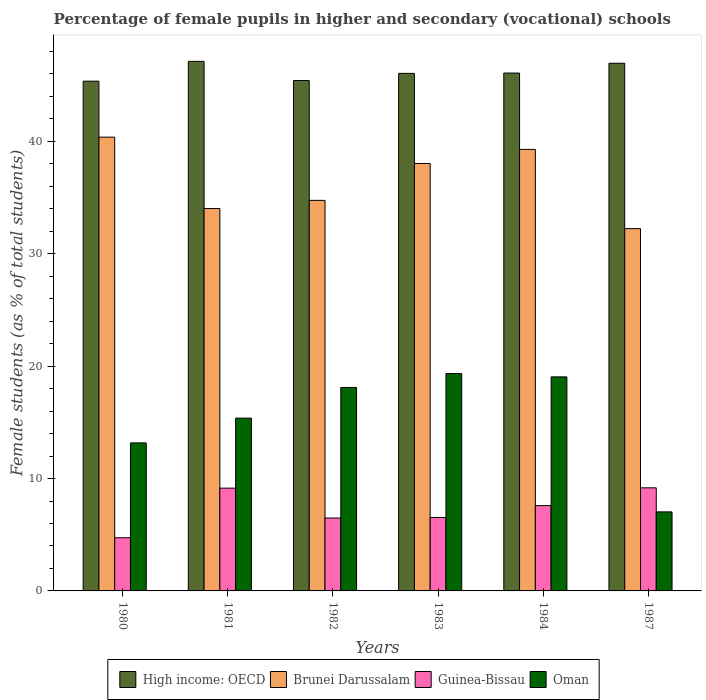How many different coloured bars are there?
Your response must be concise. 4. How many groups of bars are there?
Make the answer very short. 6. What is the percentage of female pupils in higher and secondary schools in Brunei Darussalam in 1980?
Give a very brief answer. 40.37. Across all years, what is the maximum percentage of female pupils in higher and secondary schools in High income: OECD?
Your response must be concise. 47.12. Across all years, what is the minimum percentage of female pupils in higher and secondary schools in Guinea-Bissau?
Keep it short and to the point. 4.73. In which year was the percentage of female pupils in higher and secondary schools in Oman maximum?
Make the answer very short. 1983. In which year was the percentage of female pupils in higher and secondary schools in High income: OECD minimum?
Offer a terse response. 1980. What is the total percentage of female pupils in higher and secondary schools in Brunei Darussalam in the graph?
Make the answer very short. 218.69. What is the difference between the percentage of female pupils in higher and secondary schools in Oman in 1981 and that in 1987?
Your answer should be compact. 8.34. What is the difference between the percentage of female pupils in higher and secondary schools in Guinea-Bissau in 1981 and the percentage of female pupils in higher and secondary schools in Oman in 1982?
Your answer should be very brief. -8.96. What is the average percentage of female pupils in higher and secondary schools in Oman per year?
Your response must be concise. 15.34. In the year 1982, what is the difference between the percentage of female pupils in higher and secondary schools in Brunei Darussalam and percentage of female pupils in higher and secondary schools in Guinea-Bissau?
Offer a terse response. 28.26. In how many years, is the percentage of female pupils in higher and secondary schools in High income: OECD greater than 38 %?
Your answer should be compact. 6. What is the ratio of the percentage of female pupils in higher and secondary schools in Oman in 1981 to that in 1984?
Provide a succinct answer. 0.81. Is the percentage of female pupils in higher and secondary schools in Brunei Darussalam in 1983 less than that in 1987?
Offer a terse response. No. What is the difference between the highest and the second highest percentage of female pupils in higher and secondary schools in High income: OECD?
Provide a succinct answer. 0.17. What is the difference between the highest and the lowest percentage of female pupils in higher and secondary schools in High income: OECD?
Your answer should be compact. 1.76. Is it the case that in every year, the sum of the percentage of female pupils in higher and secondary schools in Guinea-Bissau and percentage of female pupils in higher and secondary schools in Oman is greater than the sum of percentage of female pupils in higher and secondary schools in Brunei Darussalam and percentage of female pupils in higher and secondary schools in High income: OECD?
Provide a succinct answer. Yes. What does the 4th bar from the left in 1984 represents?
Provide a succinct answer. Oman. What does the 4th bar from the right in 1987 represents?
Ensure brevity in your answer.  High income: OECD. Are all the bars in the graph horizontal?
Your answer should be compact. No. What is the difference between two consecutive major ticks on the Y-axis?
Offer a terse response. 10. Are the values on the major ticks of Y-axis written in scientific E-notation?
Your answer should be very brief. No. Where does the legend appear in the graph?
Give a very brief answer. Bottom center. How many legend labels are there?
Your answer should be compact. 4. What is the title of the graph?
Provide a succinct answer. Percentage of female pupils in higher and secondary (vocational) schools. What is the label or title of the X-axis?
Provide a succinct answer. Years. What is the label or title of the Y-axis?
Provide a short and direct response. Female students (as % of total students). What is the Female students (as % of total students) in High income: OECD in 1980?
Offer a terse response. 45.35. What is the Female students (as % of total students) in Brunei Darussalam in 1980?
Your answer should be compact. 40.37. What is the Female students (as % of total students) of Guinea-Bissau in 1980?
Your answer should be very brief. 4.73. What is the Female students (as % of total students) of Oman in 1980?
Your answer should be compact. 13.17. What is the Female students (as % of total students) in High income: OECD in 1981?
Keep it short and to the point. 47.12. What is the Female students (as % of total students) of Brunei Darussalam in 1981?
Keep it short and to the point. 34.02. What is the Female students (as % of total students) of Guinea-Bissau in 1981?
Your response must be concise. 9.14. What is the Female students (as % of total students) in Oman in 1981?
Your answer should be very brief. 15.37. What is the Female students (as % of total students) of High income: OECD in 1982?
Provide a succinct answer. 45.41. What is the Female students (as % of total students) in Brunei Darussalam in 1982?
Your answer should be compact. 34.75. What is the Female students (as % of total students) of Guinea-Bissau in 1982?
Keep it short and to the point. 6.49. What is the Female students (as % of total students) in Oman in 1982?
Make the answer very short. 18.1. What is the Female students (as % of total students) of High income: OECD in 1983?
Make the answer very short. 46.05. What is the Female students (as % of total students) of Brunei Darussalam in 1983?
Ensure brevity in your answer.  38.03. What is the Female students (as % of total students) in Guinea-Bissau in 1983?
Give a very brief answer. 6.54. What is the Female students (as % of total students) of Oman in 1983?
Your answer should be compact. 19.34. What is the Female students (as % of total students) in High income: OECD in 1984?
Your answer should be very brief. 46.08. What is the Female students (as % of total students) in Brunei Darussalam in 1984?
Your answer should be compact. 39.28. What is the Female students (as % of total students) of Guinea-Bissau in 1984?
Make the answer very short. 7.59. What is the Female students (as % of total students) of Oman in 1984?
Make the answer very short. 19.04. What is the Female students (as % of total students) of High income: OECD in 1987?
Provide a succinct answer. 46.95. What is the Female students (as % of total students) in Brunei Darussalam in 1987?
Offer a terse response. 32.24. What is the Female students (as % of total students) in Guinea-Bissau in 1987?
Your answer should be compact. 9.17. What is the Female students (as % of total students) in Oman in 1987?
Offer a terse response. 7.03. Across all years, what is the maximum Female students (as % of total students) in High income: OECD?
Provide a succinct answer. 47.12. Across all years, what is the maximum Female students (as % of total students) in Brunei Darussalam?
Ensure brevity in your answer.  40.37. Across all years, what is the maximum Female students (as % of total students) of Guinea-Bissau?
Give a very brief answer. 9.17. Across all years, what is the maximum Female students (as % of total students) in Oman?
Your response must be concise. 19.34. Across all years, what is the minimum Female students (as % of total students) in High income: OECD?
Provide a short and direct response. 45.35. Across all years, what is the minimum Female students (as % of total students) of Brunei Darussalam?
Offer a terse response. 32.24. Across all years, what is the minimum Female students (as % of total students) in Guinea-Bissau?
Provide a short and direct response. 4.73. Across all years, what is the minimum Female students (as % of total students) in Oman?
Your answer should be very brief. 7.03. What is the total Female students (as % of total students) of High income: OECD in the graph?
Give a very brief answer. 276.96. What is the total Female students (as % of total students) of Brunei Darussalam in the graph?
Provide a succinct answer. 218.69. What is the total Female students (as % of total students) of Guinea-Bissau in the graph?
Offer a very short reply. 43.66. What is the total Female students (as % of total students) in Oman in the graph?
Offer a very short reply. 92.07. What is the difference between the Female students (as % of total students) in High income: OECD in 1980 and that in 1981?
Your answer should be very brief. -1.76. What is the difference between the Female students (as % of total students) of Brunei Darussalam in 1980 and that in 1981?
Provide a succinct answer. 6.35. What is the difference between the Female students (as % of total students) of Guinea-Bissau in 1980 and that in 1981?
Offer a very short reply. -4.41. What is the difference between the Female students (as % of total students) in Oman in 1980 and that in 1981?
Offer a terse response. -2.2. What is the difference between the Female students (as % of total students) of High income: OECD in 1980 and that in 1982?
Offer a terse response. -0.06. What is the difference between the Female students (as % of total students) of Brunei Darussalam in 1980 and that in 1982?
Offer a very short reply. 5.62. What is the difference between the Female students (as % of total students) of Guinea-Bissau in 1980 and that in 1982?
Provide a short and direct response. -1.75. What is the difference between the Female students (as % of total students) of Oman in 1980 and that in 1982?
Your answer should be very brief. -4.93. What is the difference between the Female students (as % of total students) in High income: OECD in 1980 and that in 1983?
Give a very brief answer. -0.69. What is the difference between the Female students (as % of total students) in Brunei Darussalam in 1980 and that in 1983?
Ensure brevity in your answer.  2.34. What is the difference between the Female students (as % of total students) of Guinea-Bissau in 1980 and that in 1983?
Offer a very short reply. -1.8. What is the difference between the Female students (as % of total students) of Oman in 1980 and that in 1983?
Your response must be concise. -6.17. What is the difference between the Female students (as % of total students) in High income: OECD in 1980 and that in 1984?
Your answer should be compact. -0.72. What is the difference between the Female students (as % of total students) in Brunei Darussalam in 1980 and that in 1984?
Offer a very short reply. 1.09. What is the difference between the Female students (as % of total students) of Guinea-Bissau in 1980 and that in 1984?
Make the answer very short. -2.86. What is the difference between the Female students (as % of total students) in Oman in 1980 and that in 1984?
Ensure brevity in your answer.  -5.87. What is the difference between the Female students (as % of total students) in High income: OECD in 1980 and that in 1987?
Your response must be concise. -1.6. What is the difference between the Female students (as % of total students) in Brunei Darussalam in 1980 and that in 1987?
Your answer should be compact. 8.14. What is the difference between the Female students (as % of total students) in Guinea-Bissau in 1980 and that in 1987?
Your answer should be very brief. -4.44. What is the difference between the Female students (as % of total students) of Oman in 1980 and that in 1987?
Your answer should be compact. 6.14. What is the difference between the Female students (as % of total students) in High income: OECD in 1981 and that in 1982?
Keep it short and to the point. 1.71. What is the difference between the Female students (as % of total students) of Brunei Darussalam in 1981 and that in 1982?
Provide a short and direct response. -0.73. What is the difference between the Female students (as % of total students) in Guinea-Bissau in 1981 and that in 1982?
Offer a terse response. 2.66. What is the difference between the Female students (as % of total students) of Oman in 1981 and that in 1982?
Offer a terse response. -2.73. What is the difference between the Female students (as % of total students) of High income: OECD in 1981 and that in 1983?
Offer a terse response. 1.07. What is the difference between the Female students (as % of total students) of Brunei Darussalam in 1981 and that in 1983?
Make the answer very short. -4.01. What is the difference between the Female students (as % of total students) of Guinea-Bissau in 1981 and that in 1983?
Keep it short and to the point. 2.61. What is the difference between the Female students (as % of total students) in Oman in 1981 and that in 1983?
Your answer should be very brief. -3.97. What is the difference between the Female students (as % of total students) of High income: OECD in 1981 and that in 1984?
Provide a succinct answer. 1.04. What is the difference between the Female students (as % of total students) of Brunei Darussalam in 1981 and that in 1984?
Make the answer very short. -5.26. What is the difference between the Female students (as % of total students) of Guinea-Bissau in 1981 and that in 1984?
Ensure brevity in your answer.  1.55. What is the difference between the Female students (as % of total students) in Oman in 1981 and that in 1984?
Provide a short and direct response. -3.67. What is the difference between the Female students (as % of total students) of High income: OECD in 1981 and that in 1987?
Your response must be concise. 0.17. What is the difference between the Female students (as % of total students) in Brunei Darussalam in 1981 and that in 1987?
Keep it short and to the point. 1.79. What is the difference between the Female students (as % of total students) of Guinea-Bissau in 1981 and that in 1987?
Keep it short and to the point. -0.03. What is the difference between the Female students (as % of total students) of Oman in 1981 and that in 1987?
Your answer should be very brief. 8.34. What is the difference between the Female students (as % of total students) of High income: OECD in 1982 and that in 1983?
Offer a very short reply. -0.64. What is the difference between the Female students (as % of total students) of Brunei Darussalam in 1982 and that in 1983?
Provide a short and direct response. -3.28. What is the difference between the Female students (as % of total students) in Guinea-Bissau in 1982 and that in 1983?
Ensure brevity in your answer.  -0.05. What is the difference between the Female students (as % of total students) in Oman in 1982 and that in 1983?
Provide a succinct answer. -1.24. What is the difference between the Female students (as % of total students) in High income: OECD in 1982 and that in 1984?
Your answer should be compact. -0.67. What is the difference between the Female students (as % of total students) of Brunei Darussalam in 1982 and that in 1984?
Keep it short and to the point. -4.53. What is the difference between the Female students (as % of total students) of Guinea-Bissau in 1982 and that in 1984?
Keep it short and to the point. -1.1. What is the difference between the Female students (as % of total students) of Oman in 1982 and that in 1984?
Your response must be concise. -0.94. What is the difference between the Female students (as % of total students) of High income: OECD in 1982 and that in 1987?
Make the answer very short. -1.54. What is the difference between the Female students (as % of total students) in Brunei Darussalam in 1982 and that in 1987?
Ensure brevity in your answer.  2.51. What is the difference between the Female students (as % of total students) in Guinea-Bissau in 1982 and that in 1987?
Provide a succinct answer. -2.69. What is the difference between the Female students (as % of total students) of Oman in 1982 and that in 1987?
Keep it short and to the point. 11.07. What is the difference between the Female students (as % of total students) of High income: OECD in 1983 and that in 1984?
Your response must be concise. -0.03. What is the difference between the Female students (as % of total students) in Brunei Darussalam in 1983 and that in 1984?
Make the answer very short. -1.25. What is the difference between the Female students (as % of total students) of Guinea-Bissau in 1983 and that in 1984?
Make the answer very short. -1.05. What is the difference between the Female students (as % of total students) in Oman in 1983 and that in 1984?
Your answer should be compact. 0.3. What is the difference between the Female students (as % of total students) in High income: OECD in 1983 and that in 1987?
Your answer should be compact. -0.9. What is the difference between the Female students (as % of total students) in Brunei Darussalam in 1983 and that in 1987?
Offer a very short reply. 5.79. What is the difference between the Female students (as % of total students) in Guinea-Bissau in 1983 and that in 1987?
Provide a short and direct response. -2.64. What is the difference between the Female students (as % of total students) in Oman in 1983 and that in 1987?
Make the answer very short. 12.31. What is the difference between the Female students (as % of total students) in High income: OECD in 1984 and that in 1987?
Provide a succinct answer. -0.87. What is the difference between the Female students (as % of total students) in Brunei Darussalam in 1984 and that in 1987?
Your answer should be very brief. 7.05. What is the difference between the Female students (as % of total students) in Guinea-Bissau in 1984 and that in 1987?
Keep it short and to the point. -1.58. What is the difference between the Female students (as % of total students) of Oman in 1984 and that in 1987?
Offer a very short reply. 12.01. What is the difference between the Female students (as % of total students) of High income: OECD in 1980 and the Female students (as % of total students) of Brunei Darussalam in 1981?
Offer a terse response. 11.33. What is the difference between the Female students (as % of total students) of High income: OECD in 1980 and the Female students (as % of total students) of Guinea-Bissau in 1981?
Offer a terse response. 36.21. What is the difference between the Female students (as % of total students) of High income: OECD in 1980 and the Female students (as % of total students) of Oman in 1981?
Provide a short and direct response. 29.98. What is the difference between the Female students (as % of total students) in Brunei Darussalam in 1980 and the Female students (as % of total students) in Guinea-Bissau in 1981?
Make the answer very short. 31.23. What is the difference between the Female students (as % of total students) of Brunei Darussalam in 1980 and the Female students (as % of total students) of Oman in 1981?
Offer a very short reply. 25. What is the difference between the Female students (as % of total students) in Guinea-Bissau in 1980 and the Female students (as % of total students) in Oman in 1981?
Your response must be concise. -10.64. What is the difference between the Female students (as % of total students) of High income: OECD in 1980 and the Female students (as % of total students) of Brunei Darussalam in 1982?
Make the answer very short. 10.61. What is the difference between the Female students (as % of total students) of High income: OECD in 1980 and the Female students (as % of total students) of Guinea-Bissau in 1982?
Ensure brevity in your answer.  38.87. What is the difference between the Female students (as % of total students) in High income: OECD in 1980 and the Female students (as % of total students) in Oman in 1982?
Keep it short and to the point. 27.25. What is the difference between the Female students (as % of total students) in Brunei Darussalam in 1980 and the Female students (as % of total students) in Guinea-Bissau in 1982?
Offer a terse response. 33.89. What is the difference between the Female students (as % of total students) of Brunei Darussalam in 1980 and the Female students (as % of total students) of Oman in 1982?
Keep it short and to the point. 22.27. What is the difference between the Female students (as % of total students) of Guinea-Bissau in 1980 and the Female students (as % of total students) of Oman in 1982?
Provide a succinct answer. -13.37. What is the difference between the Female students (as % of total students) of High income: OECD in 1980 and the Female students (as % of total students) of Brunei Darussalam in 1983?
Give a very brief answer. 7.33. What is the difference between the Female students (as % of total students) in High income: OECD in 1980 and the Female students (as % of total students) in Guinea-Bissau in 1983?
Offer a very short reply. 38.82. What is the difference between the Female students (as % of total students) in High income: OECD in 1980 and the Female students (as % of total students) in Oman in 1983?
Your answer should be very brief. 26.01. What is the difference between the Female students (as % of total students) of Brunei Darussalam in 1980 and the Female students (as % of total students) of Guinea-Bissau in 1983?
Offer a very short reply. 33.84. What is the difference between the Female students (as % of total students) of Brunei Darussalam in 1980 and the Female students (as % of total students) of Oman in 1983?
Keep it short and to the point. 21.03. What is the difference between the Female students (as % of total students) in Guinea-Bissau in 1980 and the Female students (as % of total students) in Oman in 1983?
Your answer should be compact. -14.61. What is the difference between the Female students (as % of total students) of High income: OECD in 1980 and the Female students (as % of total students) of Brunei Darussalam in 1984?
Make the answer very short. 6.07. What is the difference between the Female students (as % of total students) of High income: OECD in 1980 and the Female students (as % of total students) of Guinea-Bissau in 1984?
Make the answer very short. 37.76. What is the difference between the Female students (as % of total students) in High income: OECD in 1980 and the Female students (as % of total students) in Oman in 1984?
Your answer should be very brief. 26.31. What is the difference between the Female students (as % of total students) in Brunei Darussalam in 1980 and the Female students (as % of total students) in Guinea-Bissau in 1984?
Your answer should be compact. 32.78. What is the difference between the Female students (as % of total students) of Brunei Darussalam in 1980 and the Female students (as % of total students) of Oman in 1984?
Your answer should be very brief. 21.33. What is the difference between the Female students (as % of total students) in Guinea-Bissau in 1980 and the Female students (as % of total students) in Oman in 1984?
Give a very brief answer. -14.31. What is the difference between the Female students (as % of total students) of High income: OECD in 1980 and the Female students (as % of total students) of Brunei Darussalam in 1987?
Your response must be concise. 13.12. What is the difference between the Female students (as % of total students) in High income: OECD in 1980 and the Female students (as % of total students) in Guinea-Bissau in 1987?
Give a very brief answer. 36.18. What is the difference between the Female students (as % of total students) in High income: OECD in 1980 and the Female students (as % of total students) in Oman in 1987?
Offer a terse response. 38.32. What is the difference between the Female students (as % of total students) in Brunei Darussalam in 1980 and the Female students (as % of total students) in Guinea-Bissau in 1987?
Make the answer very short. 31.2. What is the difference between the Female students (as % of total students) of Brunei Darussalam in 1980 and the Female students (as % of total students) of Oman in 1987?
Provide a succinct answer. 33.34. What is the difference between the Female students (as % of total students) of Guinea-Bissau in 1980 and the Female students (as % of total students) of Oman in 1987?
Provide a short and direct response. -2.3. What is the difference between the Female students (as % of total students) in High income: OECD in 1981 and the Female students (as % of total students) in Brunei Darussalam in 1982?
Provide a succinct answer. 12.37. What is the difference between the Female students (as % of total students) of High income: OECD in 1981 and the Female students (as % of total students) of Guinea-Bissau in 1982?
Your answer should be very brief. 40.63. What is the difference between the Female students (as % of total students) in High income: OECD in 1981 and the Female students (as % of total students) in Oman in 1982?
Offer a terse response. 29.01. What is the difference between the Female students (as % of total students) in Brunei Darussalam in 1981 and the Female students (as % of total students) in Guinea-Bissau in 1982?
Ensure brevity in your answer.  27.54. What is the difference between the Female students (as % of total students) of Brunei Darussalam in 1981 and the Female students (as % of total students) of Oman in 1982?
Provide a succinct answer. 15.92. What is the difference between the Female students (as % of total students) of Guinea-Bissau in 1981 and the Female students (as % of total students) of Oman in 1982?
Provide a succinct answer. -8.96. What is the difference between the Female students (as % of total students) of High income: OECD in 1981 and the Female students (as % of total students) of Brunei Darussalam in 1983?
Keep it short and to the point. 9.09. What is the difference between the Female students (as % of total students) in High income: OECD in 1981 and the Female students (as % of total students) in Guinea-Bissau in 1983?
Provide a short and direct response. 40.58. What is the difference between the Female students (as % of total students) of High income: OECD in 1981 and the Female students (as % of total students) of Oman in 1983?
Provide a short and direct response. 27.78. What is the difference between the Female students (as % of total students) in Brunei Darussalam in 1981 and the Female students (as % of total students) in Guinea-Bissau in 1983?
Offer a very short reply. 27.49. What is the difference between the Female students (as % of total students) of Brunei Darussalam in 1981 and the Female students (as % of total students) of Oman in 1983?
Offer a terse response. 14.68. What is the difference between the Female students (as % of total students) in Guinea-Bissau in 1981 and the Female students (as % of total students) in Oman in 1983?
Give a very brief answer. -10.2. What is the difference between the Female students (as % of total students) of High income: OECD in 1981 and the Female students (as % of total students) of Brunei Darussalam in 1984?
Ensure brevity in your answer.  7.83. What is the difference between the Female students (as % of total students) in High income: OECD in 1981 and the Female students (as % of total students) in Guinea-Bissau in 1984?
Your response must be concise. 39.53. What is the difference between the Female students (as % of total students) of High income: OECD in 1981 and the Female students (as % of total students) of Oman in 1984?
Your answer should be compact. 28.07. What is the difference between the Female students (as % of total students) of Brunei Darussalam in 1981 and the Female students (as % of total students) of Guinea-Bissau in 1984?
Keep it short and to the point. 26.43. What is the difference between the Female students (as % of total students) of Brunei Darussalam in 1981 and the Female students (as % of total students) of Oman in 1984?
Offer a very short reply. 14.98. What is the difference between the Female students (as % of total students) in Guinea-Bissau in 1981 and the Female students (as % of total students) in Oman in 1984?
Make the answer very short. -9.9. What is the difference between the Female students (as % of total students) in High income: OECD in 1981 and the Female students (as % of total students) in Brunei Darussalam in 1987?
Give a very brief answer. 14.88. What is the difference between the Female students (as % of total students) of High income: OECD in 1981 and the Female students (as % of total students) of Guinea-Bissau in 1987?
Offer a very short reply. 37.95. What is the difference between the Female students (as % of total students) of High income: OECD in 1981 and the Female students (as % of total students) of Oman in 1987?
Give a very brief answer. 40.08. What is the difference between the Female students (as % of total students) of Brunei Darussalam in 1981 and the Female students (as % of total students) of Guinea-Bissau in 1987?
Provide a short and direct response. 24.85. What is the difference between the Female students (as % of total students) in Brunei Darussalam in 1981 and the Female students (as % of total students) in Oman in 1987?
Your response must be concise. 26.99. What is the difference between the Female students (as % of total students) of Guinea-Bissau in 1981 and the Female students (as % of total students) of Oman in 1987?
Your answer should be compact. 2.11. What is the difference between the Female students (as % of total students) of High income: OECD in 1982 and the Female students (as % of total students) of Brunei Darussalam in 1983?
Provide a short and direct response. 7.38. What is the difference between the Female students (as % of total students) of High income: OECD in 1982 and the Female students (as % of total students) of Guinea-Bissau in 1983?
Provide a succinct answer. 38.87. What is the difference between the Female students (as % of total students) in High income: OECD in 1982 and the Female students (as % of total students) in Oman in 1983?
Provide a short and direct response. 26.07. What is the difference between the Female students (as % of total students) in Brunei Darussalam in 1982 and the Female students (as % of total students) in Guinea-Bissau in 1983?
Provide a short and direct response. 28.21. What is the difference between the Female students (as % of total students) in Brunei Darussalam in 1982 and the Female students (as % of total students) in Oman in 1983?
Provide a succinct answer. 15.41. What is the difference between the Female students (as % of total students) in Guinea-Bissau in 1982 and the Female students (as % of total students) in Oman in 1983?
Provide a succinct answer. -12.85. What is the difference between the Female students (as % of total students) of High income: OECD in 1982 and the Female students (as % of total students) of Brunei Darussalam in 1984?
Keep it short and to the point. 6.13. What is the difference between the Female students (as % of total students) in High income: OECD in 1982 and the Female students (as % of total students) in Guinea-Bissau in 1984?
Provide a short and direct response. 37.82. What is the difference between the Female students (as % of total students) in High income: OECD in 1982 and the Female students (as % of total students) in Oman in 1984?
Offer a very short reply. 26.37. What is the difference between the Female students (as % of total students) of Brunei Darussalam in 1982 and the Female students (as % of total students) of Guinea-Bissau in 1984?
Offer a terse response. 27.16. What is the difference between the Female students (as % of total students) in Brunei Darussalam in 1982 and the Female students (as % of total students) in Oman in 1984?
Make the answer very short. 15.7. What is the difference between the Female students (as % of total students) of Guinea-Bissau in 1982 and the Female students (as % of total students) of Oman in 1984?
Provide a short and direct response. -12.56. What is the difference between the Female students (as % of total students) in High income: OECD in 1982 and the Female students (as % of total students) in Brunei Darussalam in 1987?
Your answer should be very brief. 13.17. What is the difference between the Female students (as % of total students) in High income: OECD in 1982 and the Female students (as % of total students) in Guinea-Bissau in 1987?
Ensure brevity in your answer.  36.24. What is the difference between the Female students (as % of total students) of High income: OECD in 1982 and the Female students (as % of total students) of Oman in 1987?
Your answer should be very brief. 38.38. What is the difference between the Female students (as % of total students) of Brunei Darussalam in 1982 and the Female students (as % of total students) of Guinea-Bissau in 1987?
Provide a succinct answer. 25.58. What is the difference between the Female students (as % of total students) of Brunei Darussalam in 1982 and the Female students (as % of total students) of Oman in 1987?
Make the answer very short. 27.72. What is the difference between the Female students (as % of total students) of Guinea-Bissau in 1982 and the Female students (as % of total students) of Oman in 1987?
Make the answer very short. -0.55. What is the difference between the Female students (as % of total students) in High income: OECD in 1983 and the Female students (as % of total students) in Brunei Darussalam in 1984?
Keep it short and to the point. 6.76. What is the difference between the Female students (as % of total students) of High income: OECD in 1983 and the Female students (as % of total students) of Guinea-Bissau in 1984?
Offer a terse response. 38.46. What is the difference between the Female students (as % of total students) in High income: OECD in 1983 and the Female students (as % of total students) in Oman in 1984?
Provide a succinct answer. 27. What is the difference between the Female students (as % of total students) of Brunei Darussalam in 1983 and the Female students (as % of total students) of Guinea-Bissau in 1984?
Provide a succinct answer. 30.44. What is the difference between the Female students (as % of total students) of Brunei Darussalam in 1983 and the Female students (as % of total students) of Oman in 1984?
Provide a short and direct response. 18.99. What is the difference between the Female students (as % of total students) in Guinea-Bissau in 1983 and the Female students (as % of total students) in Oman in 1984?
Offer a terse response. -12.51. What is the difference between the Female students (as % of total students) in High income: OECD in 1983 and the Female students (as % of total students) in Brunei Darussalam in 1987?
Keep it short and to the point. 13.81. What is the difference between the Female students (as % of total students) in High income: OECD in 1983 and the Female students (as % of total students) in Guinea-Bissau in 1987?
Your answer should be very brief. 36.88. What is the difference between the Female students (as % of total students) of High income: OECD in 1983 and the Female students (as % of total students) of Oman in 1987?
Give a very brief answer. 39.02. What is the difference between the Female students (as % of total students) of Brunei Darussalam in 1983 and the Female students (as % of total students) of Guinea-Bissau in 1987?
Your response must be concise. 28.86. What is the difference between the Female students (as % of total students) in Brunei Darussalam in 1983 and the Female students (as % of total students) in Oman in 1987?
Provide a succinct answer. 31. What is the difference between the Female students (as % of total students) in Guinea-Bissau in 1983 and the Female students (as % of total students) in Oman in 1987?
Your answer should be compact. -0.5. What is the difference between the Female students (as % of total students) of High income: OECD in 1984 and the Female students (as % of total students) of Brunei Darussalam in 1987?
Your answer should be compact. 13.84. What is the difference between the Female students (as % of total students) of High income: OECD in 1984 and the Female students (as % of total students) of Guinea-Bissau in 1987?
Offer a very short reply. 36.9. What is the difference between the Female students (as % of total students) in High income: OECD in 1984 and the Female students (as % of total students) in Oman in 1987?
Offer a very short reply. 39.04. What is the difference between the Female students (as % of total students) in Brunei Darussalam in 1984 and the Female students (as % of total students) in Guinea-Bissau in 1987?
Ensure brevity in your answer.  30.11. What is the difference between the Female students (as % of total students) of Brunei Darussalam in 1984 and the Female students (as % of total students) of Oman in 1987?
Provide a succinct answer. 32.25. What is the difference between the Female students (as % of total students) in Guinea-Bissau in 1984 and the Female students (as % of total students) in Oman in 1987?
Give a very brief answer. 0.56. What is the average Female students (as % of total students) in High income: OECD per year?
Provide a short and direct response. 46.16. What is the average Female students (as % of total students) in Brunei Darussalam per year?
Ensure brevity in your answer.  36.45. What is the average Female students (as % of total students) of Guinea-Bissau per year?
Your answer should be compact. 7.28. What is the average Female students (as % of total students) of Oman per year?
Ensure brevity in your answer.  15.34. In the year 1980, what is the difference between the Female students (as % of total students) of High income: OECD and Female students (as % of total students) of Brunei Darussalam?
Your response must be concise. 4.98. In the year 1980, what is the difference between the Female students (as % of total students) of High income: OECD and Female students (as % of total students) of Guinea-Bissau?
Your answer should be very brief. 40.62. In the year 1980, what is the difference between the Female students (as % of total students) of High income: OECD and Female students (as % of total students) of Oman?
Your answer should be compact. 32.18. In the year 1980, what is the difference between the Female students (as % of total students) in Brunei Darussalam and Female students (as % of total students) in Guinea-Bissau?
Ensure brevity in your answer.  35.64. In the year 1980, what is the difference between the Female students (as % of total students) in Brunei Darussalam and Female students (as % of total students) in Oman?
Your answer should be compact. 27.2. In the year 1980, what is the difference between the Female students (as % of total students) in Guinea-Bissau and Female students (as % of total students) in Oman?
Give a very brief answer. -8.44. In the year 1981, what is the difference between the Female students (as % of total students) of High income: OECD and Female students (as % of total students) of Brunei Darussalam?
Provide a succinct answer. 13.1. In the year 1981, what is the difference between the Female students (as % of total students) in High income: OECD and Female students (as % of total students) in Guinea-Bissau?
Provide a succinct answer. 37.97. In the year 1981, what is the difference between the Female students (as % of total students) in High income: OECD and Female students (as % of total students) in Oman?
Provide a succinct answer. 31.74. In the year 1981, what is the difference between the Female students (as % of total students) of Brunei Darussalam and Female students (as % of total students) of Guinea-Bissau?
Your answer should be compact. 24.88. In the year 1981, what is the difference between the Female students (as % of total students) in Brunei Darussalam and Female students (as % of total students) in Oman?
Your answer should be compact. 18.65. In the year 1981, what is the difference between the Female students (as % of total students) of Guinea-Bissau and Female students (as % of total students) of Oman?
Ensure brevity in your answer.  -6.23. In the year 1982, what is the difference between the Female students (as % of total students) of High income: OECD and Female students (as % of total students) of Brunei Darussalam?
Give a very brief answer. 10.66. In the year 1982, what is the difference between the Female students (as % of total students) of High income: OECD and Female students (as % of total students) of Guinea-Bissau?
Give a very brief answer. 38.92. In the year 1982, what is the difference between the Female students (as % of total students) in High income: OECD and Female students (as % of total students) in Oman?
Your answer should be compact. 27.31. In the year 1982, what is the difference between the Female students (as % of total students) in Brunei Darussalam and Female students (as % of total students) in Guinea-Bissau?
Give a very brief answer. 28.26. In the year 1982, what is the difference between the Female students (as % of total students) of Brunei Darussalam and Female students (as % of total students) of Oman?
Provide a short and direct response. 16.64. In the year 1982, what is the difference between the Female students (as % of total students) in Guinea-Bissau and Female students (as % of total students) in Oman?
Your answer should be compact. -11.62. In the year 1983, what is the difference between the Female students (as % of total students) in High income: OECD and Female students (as % of total students) in Brunei Darussalam?
Give a very brief answer. 8.02. In the year 1983, what is the difference between the Female students (as % of total students) of High income: OECD and Female students (as % of total students) of Guinea-Bissau?
Offer a terse response. 39.51. In the year 1983, what is the difference between the Female students (as % of total students) in High income: OECD and Female students (as % of total students) in Oman?
Provide a succinct answer. 26.71. In the year 1983, what is the difference between the Female students (as % of total students) in Brunei Darussalam and Female students (as % of total students) in Guinea-Bissau?
Give a very brief answer. 31.49. In the year 1983, what is the difference between the Female students (as % of total students) in Brunei Darussalam and Female students (as % of total students) in Oman?
Ensure brevity in your answer.  18.69. In the year 1983, what is the difference between the Female students (as % of total students) in Guinea-Bissau and Female students (as % of total students) in Oman?
Offer a terse response. -12.8. In the year 1984, what is the difference between the Female students (as % of total students) in High income: OECD and Female students (as % of total students) in Brunei Darussalam?
Offer a terse response. 6.79. In the year 1984, what is the difference between the Female students (as % of total students) of High income: OECD and Female students (as % of total students) of Guinea-Bissau?
Your answer should be very brief. 38.49. In the year 1984, what is the difference between the Female students (as % of total students) of High income: OECD and Female students (as % of total students) of Oman?
Make the answer very short. 27.03. In the year 1984, what is the difference between the Female students (as % of total students) of Brunei Darussalam and Female students (as % of total students) of Guinea-Bissau?
Make the answer very short. 31.69. In the year 1984, what is the difference between the Female students (as % of total students) of Brunei Darussalam and Female students (as % of total students) of Oman?
Your answer should be compact. 20.24. In the year 1984, what is the difference between the Female students (as % of total students) of Guinea-Bissau and Female students (as % of total students) of Oman?
Ensure brevity in your answer.  -11.45. In the year 1987, what is the difference between the Female students (as % of total students) in High income: OECD and Female students (as % of total students) in Brunei Darussalam?
Keep it short and to the point. 14.71. In the year 1987, what is the difference between the Female students (as % of total students) of High income: OECD and Female students (as % of total students) of Guinea-Bissau?
Offer a very short reply. 37.78. In the year 1987, what is the difference between the Female students (as % of total students) of High income: OECD and Female students (as % of total students) of Oman?
Your answer should be compact. 39.92. In the year 1987, what is the difference between the Female students (as % of total students) of Brunei Darussalam and Female students (as % of total students) of Guinea-Bissau?
Offer a terse response. 23.06. In the year 1987, what is the difference between the Female students (as % of total students) of Brunei Darussalam and Female students (as % of total students) of Oman?
Provide a succinct answer. 25.2. In the year 1987, what is the difference between the Female students (as % of total students) of Guinea-Bissau and Female students (as % of total students) of Oman?
Provide a short and direct response. 2.14. What is the ratio of the Female students (as % of total students) in High income: OECD in 1980 to that in 1981?
Give a very brief answer. 0.96. What is the ratio of the Female students (as % of total students) in Brunei Darussalam in 1980 to that in 1981?
Give a very brief answer. 1.19. What is the ratio of the Female students (as % of total students) of Guinea-Bissau in 1980 to that in 1981?
Offer a terse response. 0.52. What is the ratio of the Female students (as % of total students) of Oman in 1980 to that in 1981?
Provide a short and direct response. 0.86. What is the ratio of the Female students (as % of total students) of Brunei Darussalam in 1980 to that in 1982?
Provide a succinct answer. 1.16. What is the ratio of the Female students (as % of total students) in Guinea-Bissau in 1980 to that in 1982?
Provide a short and direct response. 0.73. What is the ratio of the Female students (as % of total students) in Oman in 1980 to that in 1982?
Give a very brief answer. 0.73. What is the ratio of the Female students (as % of total students) of High income: OECD in 1980 to that in 1983?
Ensure brevity in your answer.  0.98. What is the ratio of the Female students (as % of total students) of Brunei Darussalam in 1980 to that in 1983?
Offer a terse response. 1.06. What is the ratio of the Female students (as % of total students) in Guinea-Bissau in 1980 to that in 1983?
Make the answer very short. 0.72. What is the ratio of the Female students (as % of total students) of Oman in 1980 to that in 1983?
Give a very brief answer. 0.68. What is the ratio of the Female students (as % of total students) of High income: OECD in 1980 to that in 1984?
Provide a short and direct response. 0.98. What is the ratio of the Female students (as % of total students) in Brunei Darussalam in 1980 to that in 1984?
Ensure brevity in your answer.  1.03. What is the ratio of the Female students (as % of total students) of Guinea-Bissau in 1980 to that in 1984?
Offer a very short reply. 0.62. What is the ratio of the Female students (as % of total students) of Oman in 1980 to that in 1984?
Offer a very short reply. 0.69. What is the ratio of the Female students (as % of total students) in High income: OECD in 1980 to that in 1987?
Offer a terse response. 0.97. What is the ratio of the Female students (as % of total students) of Brunei Darussalam in 1980 to that in 1987?
Your answer should be compact. 1.25. What is the ratio of the Female students (as % of total students) of Guinea-Bissau in 1980 to that in 1987?
Your answer should be very brief. 0.52. What is the ratio of the Female students (as % of total students) of Oman in 1980 to that in 1987?
Provide a short and direct response. 1.87. What is the ratio of the Female students (as % of total students) in High income: OECD in 1981 to that in 1982?
Provide a short and direct response. 1.04. What is the ratio of the Female students (as % of total students) in Brunei Darussalam in 1981 to that in 1982?
Offer a terse response. 0.98. What is the ratio of the Female students (as % of total students) of Guinea-Bissau in 1981 to that in 1982?
Your answer should be compact. 1.41. What is the ratio of the Female students (as % of total students) in Oman in 1981 to that in 1982?
Offer a very short reply. 0.85. What is the ratio of the Female students (as % of total students) in High income: OECD in 1981 to that in 1983?
Provide a short and direct response. 1.02. What is the ratio of the Female students (as % of total students) in Brunei Darussalam in 1981 to that in 1983?
Make the answer very short. 0.89. What is the ratio of the Female students (as % of total students) of Guinea-Bissau in 1981 to that in 1983?
Offer a terse response. 1.4. What is the ratio of the Female students (as % of total students) of Oman in 1981 to that in 1983?
Your answer should be very brief. 0.79. What is the ratio of the Female students (as % of total students) in High income: OECD in 1981 to that in 1984?
Your answer should be very brief. 1.02. What is the ratio of the Female students (as % of total students) in Brunei Darussalam in 1981 to that in 1984?
Give a very brief answer. 0.87. What is the ratio of the Female students (as % of total students) of Guinea-Bissau in 1981 to that in 1984?
Your answer should be very brief. 1.2. What is the ratio of the Female students (as % of total students) in Oman in 1981 to that in 1984?
Provide a succinct answer. 0.81. What is the ratio of the Female students (as % of total students) in Brunei Darussalam in 1981 to that in 1987?
Provide a short and direct response. 1.06. What is the ratio of the Female students (as % of total students) of Guinea-Bissau in 1981 to that in 1987?
Your answer should be compact. 1. What is the ratio of the Female students (as % of total students) in Oman in 1981 to that in 1987?
Make the answer very short. 2.19. What is the ratio of the Female students (as % of total students) in High income: OECD in 1982 to that in 1983?
Your response must be concise. 0.99. What is the ratio of the Female students (as % of total students) of Brunei Darussalam in 1982 to that in 1983?
Keep it short and to the point. 0.91. What is the ratio of the Female students (as % of total students) of Oman in 1982 to that in 1983?
Your answer should be compact. 0.94. What is the ratio of the Female students (as % of total students) in High income: OECD in 1982 to that in 1984?
Your response must be concise. 0.99. What is the ratio of the Female students (as % of total students) of Brunei Darussalam in 1982 to that in 1984?
Make the answer very short. 0.88. What is the ratio of the Female students (as % of total students) in Guinea-Bissau in 1982 to that in 1984?
Your answer should be compact. 0.85. What is the ratio of the Female students (as % of total students) of Oman in 1982 to that in 1984?
Provide a succinct answer. 0.95. What is the ratio of the Female students (as % of total students) of High income: OECD in 1982 to that in 1987?
Make the answer very short. 0.97. What is the ratio of the Female students (as % of total students) of Brunei Darussalam in 1982 to that in 1987?
Provide a short and direct response. 1.08. What is the ratio of the Female students (as % of total students) in Guinea-Bissau in 1982 to that in 1987?
Ensure brevity in your answer.  0.71. What is the ratio of the Female students (as % of total students) in Oman in 1982 to that in 1987?
Make the answer very short. 2.57. What is the ratio of the Female students (as % of total students) in Brunei Darussalam in 1983 to that in 1984?
Offer a terse response. 0.97. What is the ratio of the Female students (as % of total students) in Guinea-Bissau in 1983 to that in 1984?
Your response must be concise. 0.86. What is the ratio of the Female students (as % of total students) of Oman in 1983 to that in 1984?
Offer a terse response. 1.02. What is the ratio of the Female students (as % of total students) of High income: OECD in 1983 to that in 1987?
Keep it short and to the point. 0.98. What is the ratio of the Female students (as % of total students) of Brunei Darussalam in 1983 to that in 1987?
Keep it short and to the point. 1.18. What is the ratio of the Female students (as % of total students) of Guinea-Bissau in 1983 to that in 1987?
Your answer should be very brief. 0.71. What is the ratio of the Female students (as % of total students) of Oman in 1983 to that in 1987?
Give a very brief answer. 2.75. What is the ratio of the Female students (as % of total students) of High income: OECD in 1984 to that in 1987?
Ensure brevity in your answer.  0.98. What is the ratio of the Female students (as % of total students) in Brunei Darussalam in 1984 to that in 1987?
Give a very brief answer. 1.22. What is the ratio of the Female students (as % of total students) in Guinea-Bissau in 1984 to that in 1987?
Your answer should be very brief. 0.83. What is the ratio of the Female students (as % of total students) of Oman in 1984 to that in 1987?
Offer a terse response. 2.71. What is the difference between the highest and the second highest Female students (as % of total students) in High income: OECD?
Offer a terse response. 0.17. What is the difference between the highest and the second highest Female students (as % of total students) of Brunei Darussalam?
Offer a terse response. 1.09. What is the difference between the highest and the second highest Female students (as % of total students) in Guinea-Bissau?
Your response must be concise. 0.03. What is the difference between the highest and the second highest Female students (as % of total students) in Oman?
Make the answer very short. 0.3. What is the difference between the highest and the lowest Female students (as % of total students) in High income: OECD?
Your response must be concise. 1.76. What is the difference between the highest and the lowest Female students (as % of total students) of Brunei Darussalam?
Keep it short and to the point. 8.14. What is the difference between the highest and the lowest Female students (as % of total students) of Guinea-Bissau?
Ensure brevity in your answer.  4.44. What is the difference between the highest and the lowest Female students (as % of total students) in Oman?
Your response must be concise. 12.31. 